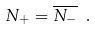<formula> <loc_0><loc_0><loc_500><loc_500>N _ { + } = \overline { N _ { - } } \ .</formula> 